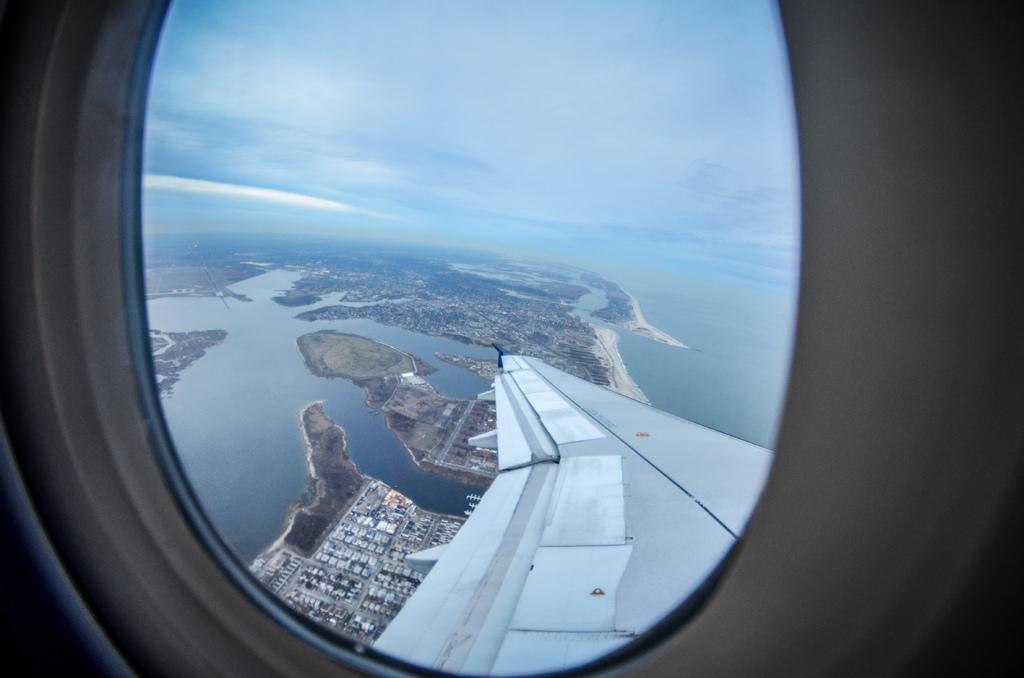What type of structure is the window in the image a part of? The window belongs to an airplane. What can be seen through the window? Buildings, rocks, and water are visible through the window. What is visible at the top of the image? The sky is visible at the top of the image. Can you hear a discussion taking place between the rocks and the water through the window? There is no discussion between the rocks and the water present in the image, as they are inanimate objects. 